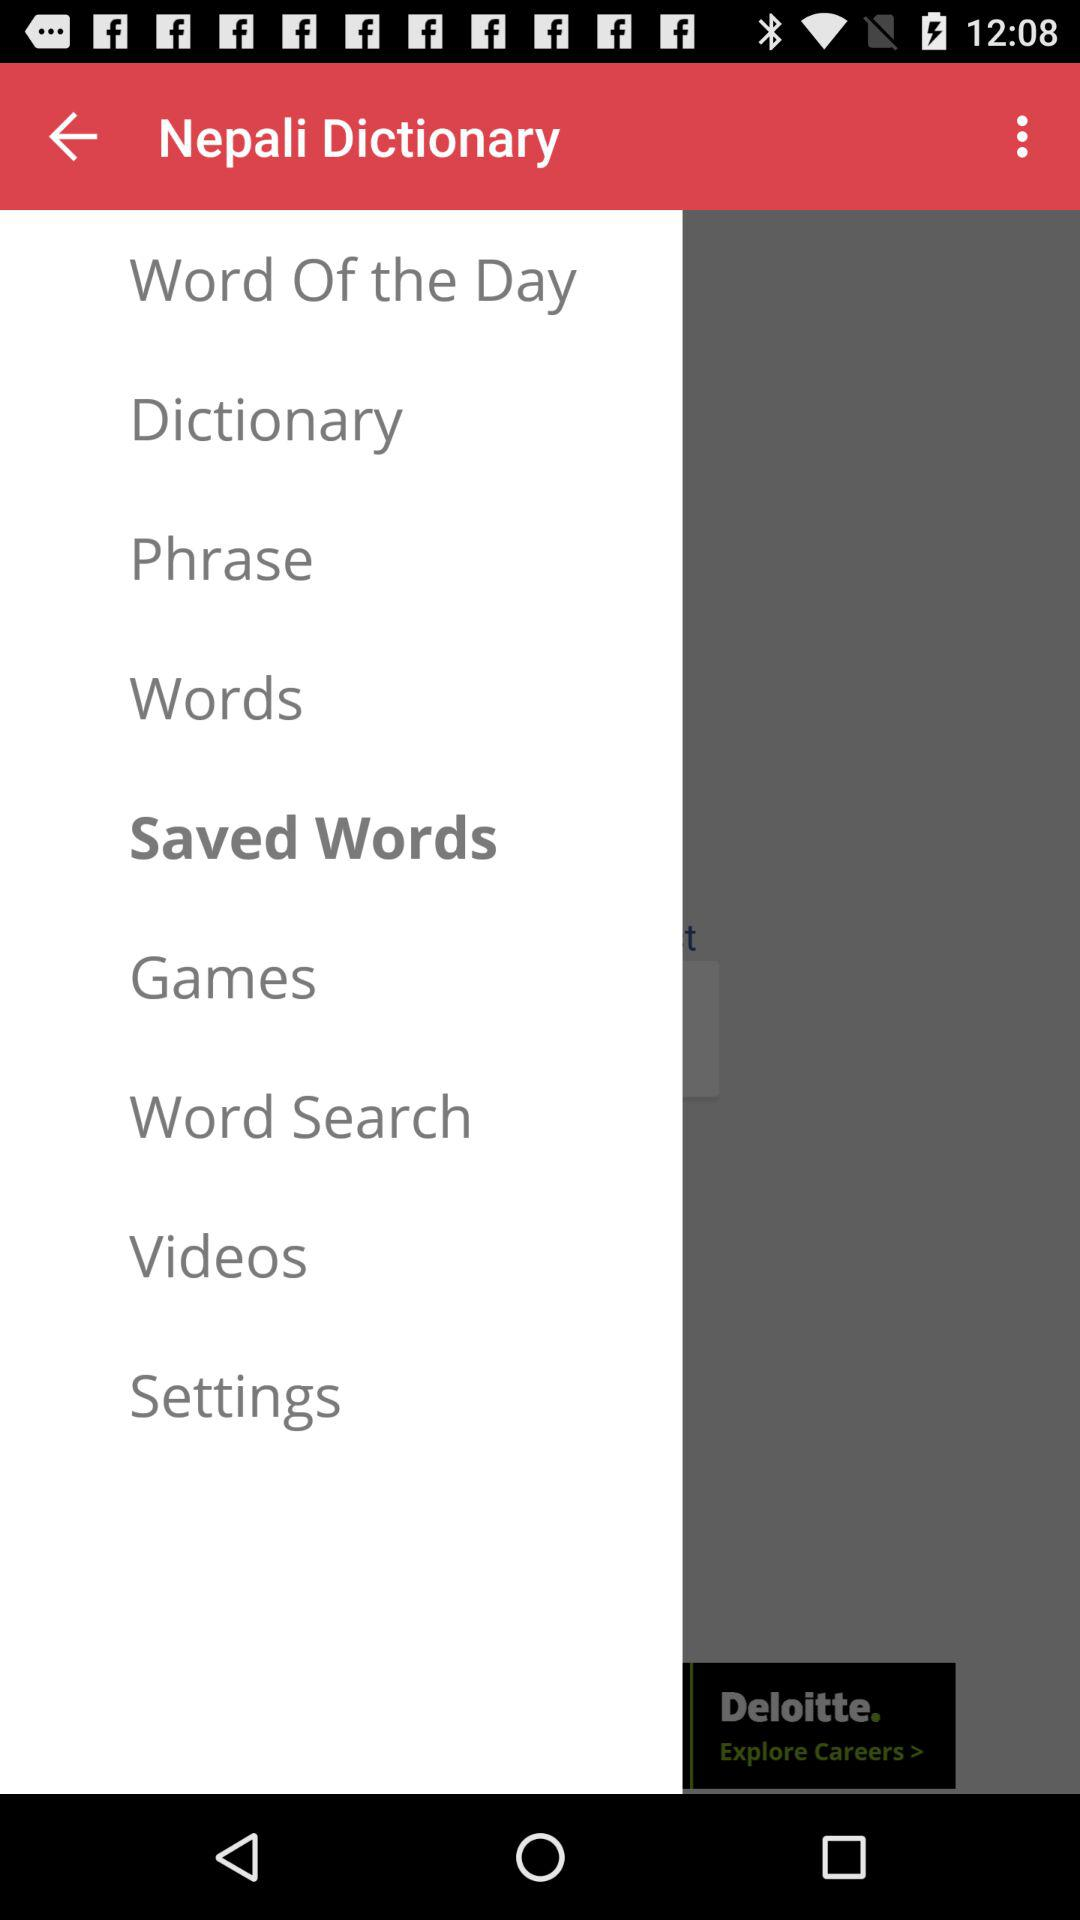Which item is selected? The selected item is "Saved Words". 